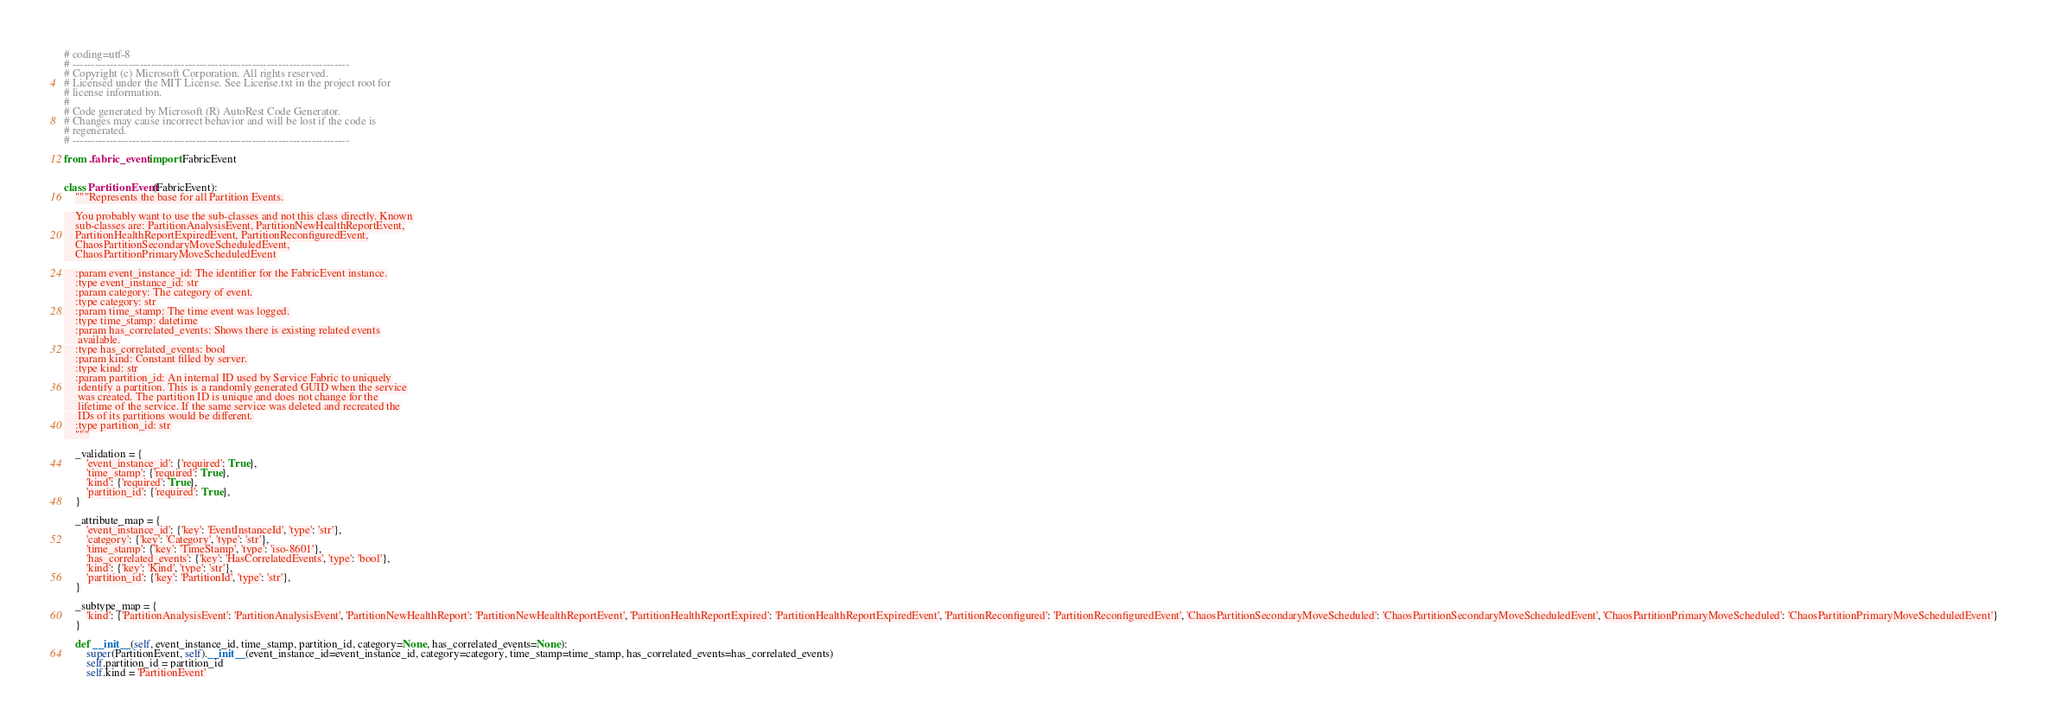Convert code to text. <code><loc_0><loc_0><loc_500><loc_500><_Python_># coding=utf-8
# --------------------------------------------------------------------------
# Copyright (c) Microsoft Corporation. All rights reserved.
# Licensed under the MIT License. See License.txt in the project root for
# license information.
#
# Code generated by Microsoft (R) AutoRest Code Generator.
# Changes may cause incorrect behavior and will be lost if the code is
# regenerated.
# --------------------------------------------------------------------------

from .fabric_event import FabricEvent


class PartitionEvent(FabricEvent):
    """Represents the base for all Partition Events.

    You probably want to use the sub-classes and not this class directly. Known
    sub-classes are: PartitionAnalysisEvent, PartitionNewHealthReportEvent,
    PartitionHealthReportExpiredEvent, PartitionReconfiguredEvent,
    ChaosPartitionSecondaryMoveScheduledEvent,
    ChaosPartitionPrimaryMoveScheduledEvent

    :param event_instance_id: The identifier for the FabricEvent instance.
    :type event_instance_id: str
    :param category: The category of event.
    :type category: str
    :param time_stamp: The time event was logged.
    :type time_stamp: datetime
    :param has_correlated_events: Shows there is existing related events
     available.
    :type has_correlated_events: bool
    :param kind: Constant filled by server.
    :type kind: str
    :param partition_id: An internal ID used by Service Fabric to uniquely
     identify a partition. This is a randomly generated GUID when the service
     was created. The partition ID is unique and does not change for the
     lifetime of the service. If the same service was deleted and recreated the
     IDs of its partitions would be different.
    :type partition_id: str
    """

    _validation = {
        'event_instance_id': {'required': True},
        'time_stamp': {'required': True},
        'kind': {'required': True},
        'partition_id': {'required': True},
    }

    _attribute_map = {
        'event_instance_id': {'key': 'EventInstanceId', 'type': 'str'},
        'category': {'key': 'Category', 'type': 'str'},
        'time_stamp': {'key': 'TimeStamp', 'type': 'iso-8601'},
        'has_correlated_events': {'key': 'HasCorrelatedEvents', 'type': 'bool'},
        'kind': {'key': 'Kind', 'type': 'str'},
        'partition_id': {'key': 'PartitionId', 'type': 'str'},
    }

    _subtype_map = {
        'kind': {'PartitionAnalysisEvent': 'PartitionAnalysisEvent', 'PartitionNewHealthReport': 'PartitionNewHealthReportEvent', 'PartitionHealthReportExpired': 'PartitionHealthReportExpiredEvent', 'PartitionReconfigured': 'PartitionReconfiguredEvent', 'ChaosPartitionSecondaryMoveScheduled': 'ChaosPartitionSecondaryMoveScheduledEvent', 'ChaosPartitionPrimaryMoveScheduled': 'ChaosPartitionPrimaryMoveScheduledEvent'}
    }

    def __init__(self, event_instance_id, time_stamp, partition_id, category=None, has_correlated_events=None):
        super(PartitionEvent, self).__init__(event_instance_id=event_instance_id, category=category, time_stamp=time_stamp, has_correlated_events=has_correlated_events)
        self.partition_id = partition_id
        self.kind = 'PartitionEvent'
</code> 